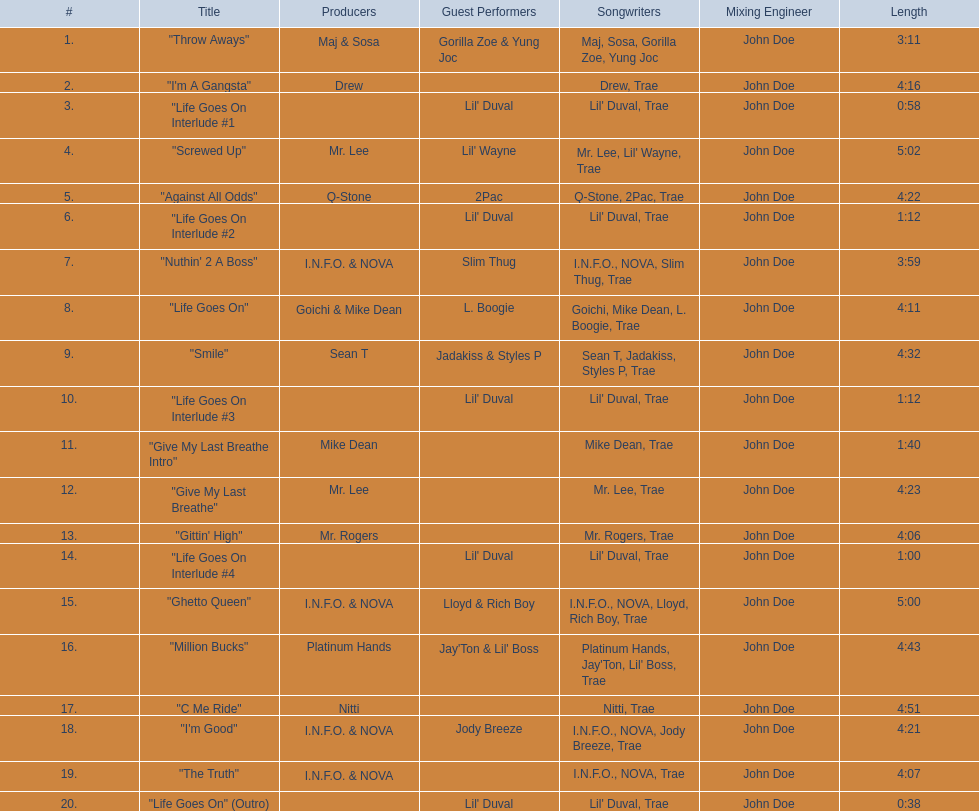What are the song lengths of all the songs on the album? 3:11, 4:16, 0:58, 5:02, 4:22, 1:12, 3:59, 4:11, 4:32, 1:12, 1:40, 4:23, 4:06, 1:00, 5:00, 4:43, 4:51, 4:21, 4:07, 0:38. Which is the longest of these? 5:02. 